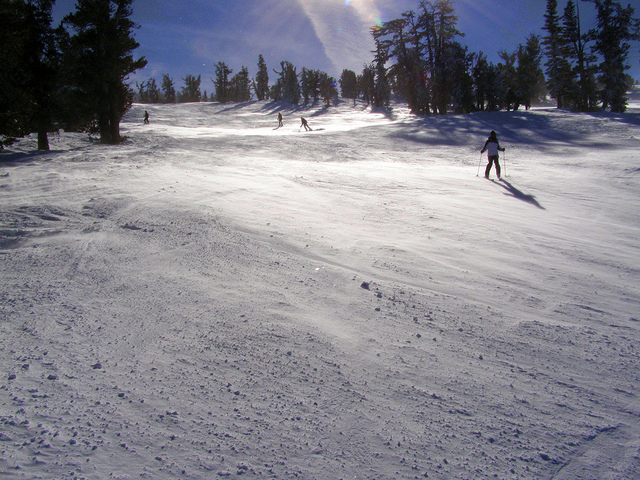<image>What caused the green dot on the photo? It's unclear what caused the green dot on the photo. It could be caused by sunlight, the camera, or light. What caused the green dot on the photo? I don't know what caused the green dot on the photo. It can be sunlight, camera or something else. 